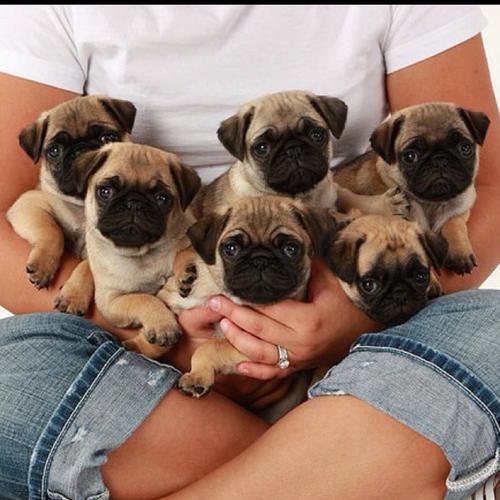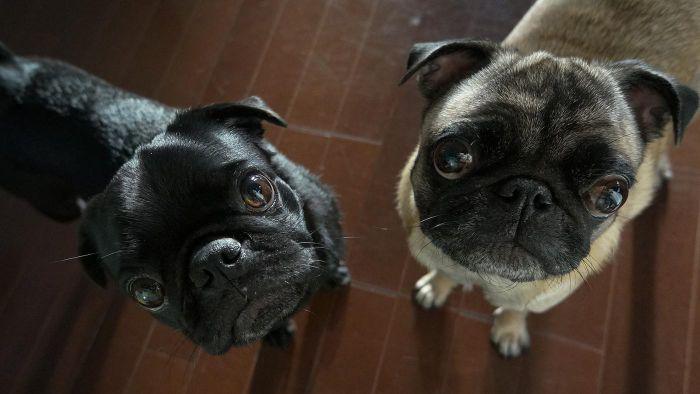The first image is the image on the left, the second image is the image on the right. For the images displayed, is the sentence "There are exactly five dogs in one of the images." factually correct? Answer yes or no. No. 